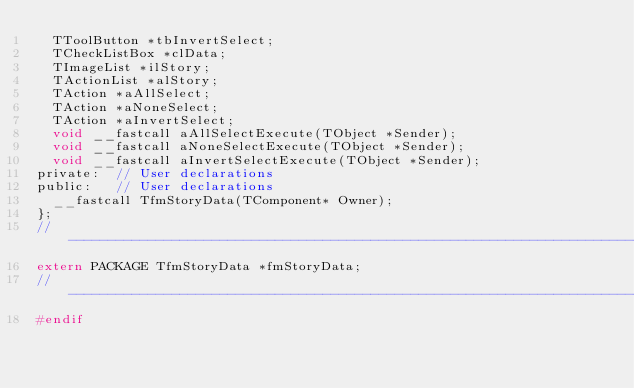<code> <loc_0><loc_0><loc_500><loc_500><_C_>  TToolButton *tbInvertSelect;
  TCheckListBox *clData;
  TImageList *ilStory;
  TActionList *alStory;
  TAction *aAllSelect;
  TAction *aNoneSelect;
  TAction *aInvertSelect;
  void __fastcall aAllSelectExecute(TObject *Sender);
  void __fastcall aNoneSelectExecute(TObject *Sender);
  void __fastcall aInvertSelectExecute(TObject *Sender);
private:	// User declarations
public:		// User declarations
  __fastcall TfmStoryData(TComponent* Owner);
};
//---------------------------------------------------------------------------
extern PACKAGE TfmStoryData *fmStoryData;
//---------------------------------------------------------------------------
#endif
</code> 